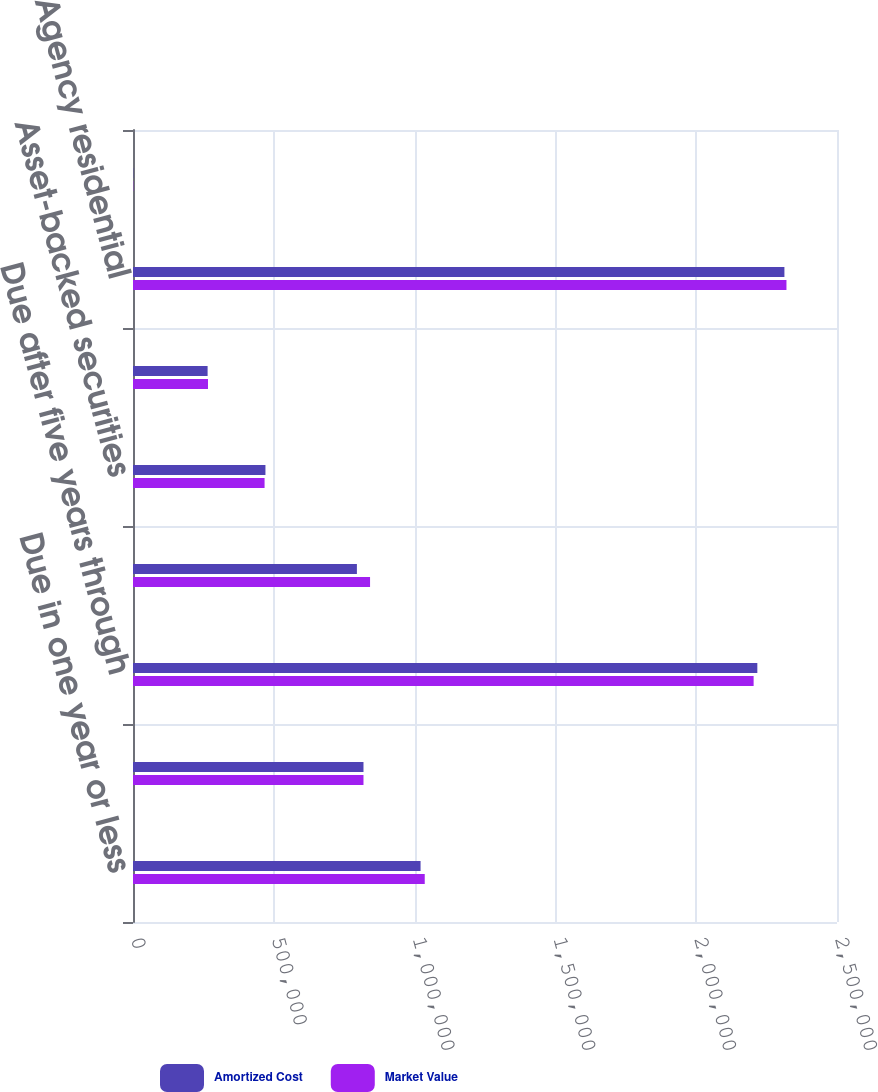Convert chart. <chart><loc_0><loc_0><loc_500><loc_500><stacked_bar_chart><ecel><fcel>Due in one year or less<fcel>Due after one year through<fcel>Due after five years through<fcel>Due after ten years<fcel>Asset-backed securities<fcel>Commercial<fcel>Agency residential<fcel>Non-agency residential<nl><fcel>Amortized Cost<fcel>1.0212e+06<fcel>818470<fcel>2.21708e+06<fcel>795103<fcel>470320<fcel>264924<fcel>2.31326e+06<fcel>893<nl><fcel>Market Value<fcel>1.03602e+06<fcel>818470<fcel>2.20393e+06<fcel>841836<fcel>467226<fcel>266299<fcel>2.32052e+06<fcel>898<nl></chart> 